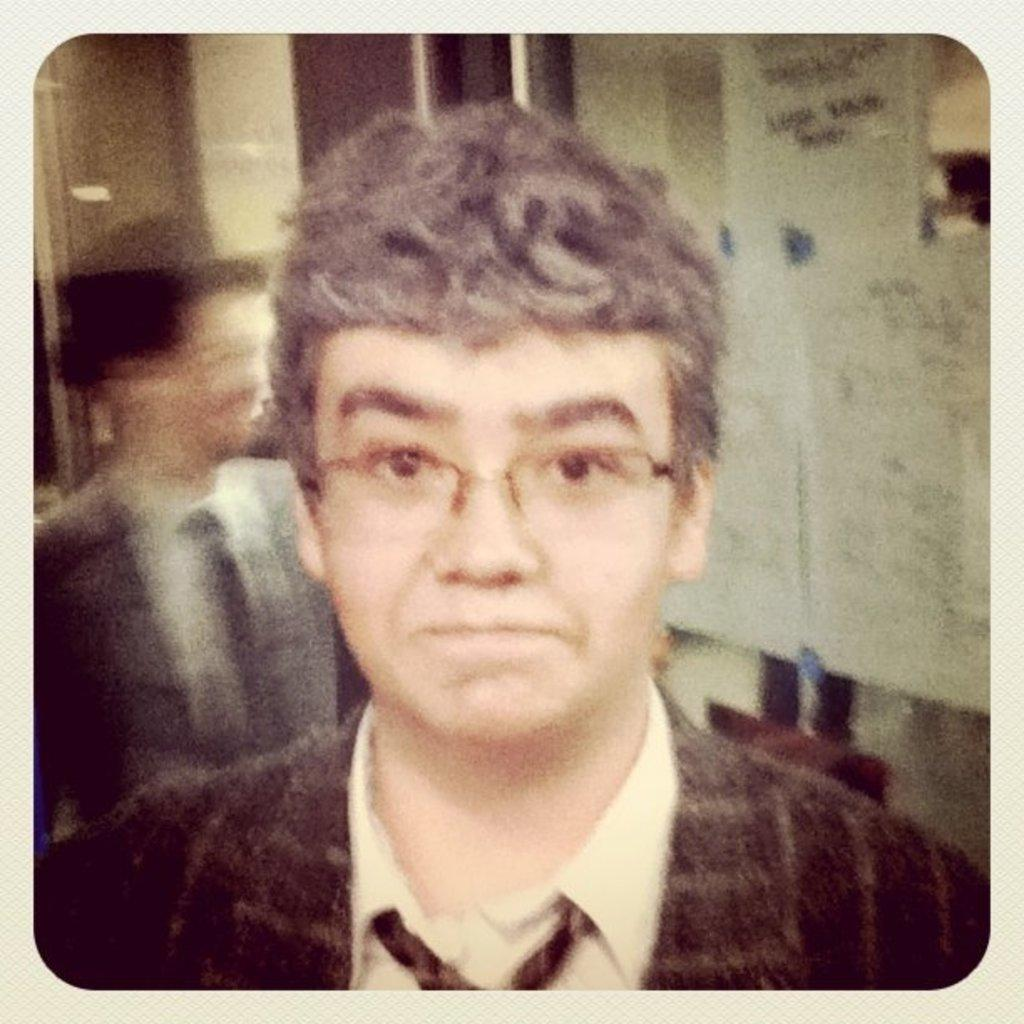What is the main subject of the image? There is a man in the image. Can you describe the man's appearance? The man is wearing spectacles. What is the background of the image like? There is a blurred image behind the man. What can be seen in the blurred image? The blurred image contains a person and papers. Where is the blurred image located? The blurred image is located on glass walls. What type of substance is being amused by the cars in the image? There are no cars or substances present in the image; it features a man with spectacles and a blurred image on glass walls. 